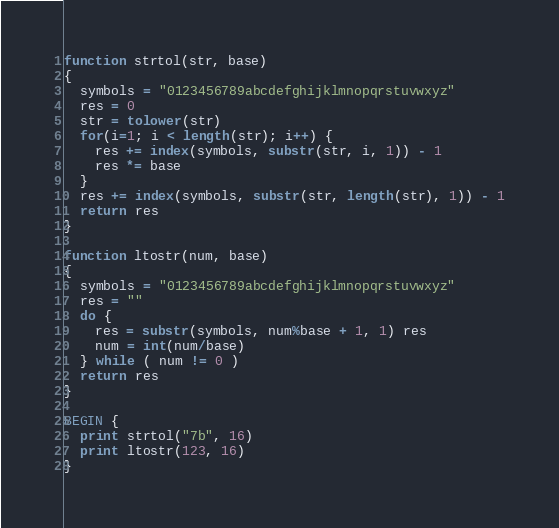Convert code to text. <code><loc_0><loc_0><loc_500><loc_500><_Awk_>function strtol(str, base)
{
  symbols = "0123456789abcdefghijklmnopqrstuvwxyz"
  res = 0
  str = tolower(str)
  for(i=1; i < length(str); i++) {
    res += index(symbols, substr(str, i, 1)) - 1
    res *= base
  }
  res += index(symbols, substr(str, length(str), 1)) - 1
  return res
}

function ltostr(num, base)
{
  symbols = "0123456789abcdefghijklmnopqrstuvwxyz"
  res = ""
  do {
    res = substr(symbols, num%base + 1, 1) res
    num = int(num/base)
  } while ( num != 0 )
  return res
}

BEGIN {
  print strtol("7b", 16)
  print ltostr(123, 16)
}
</code> 